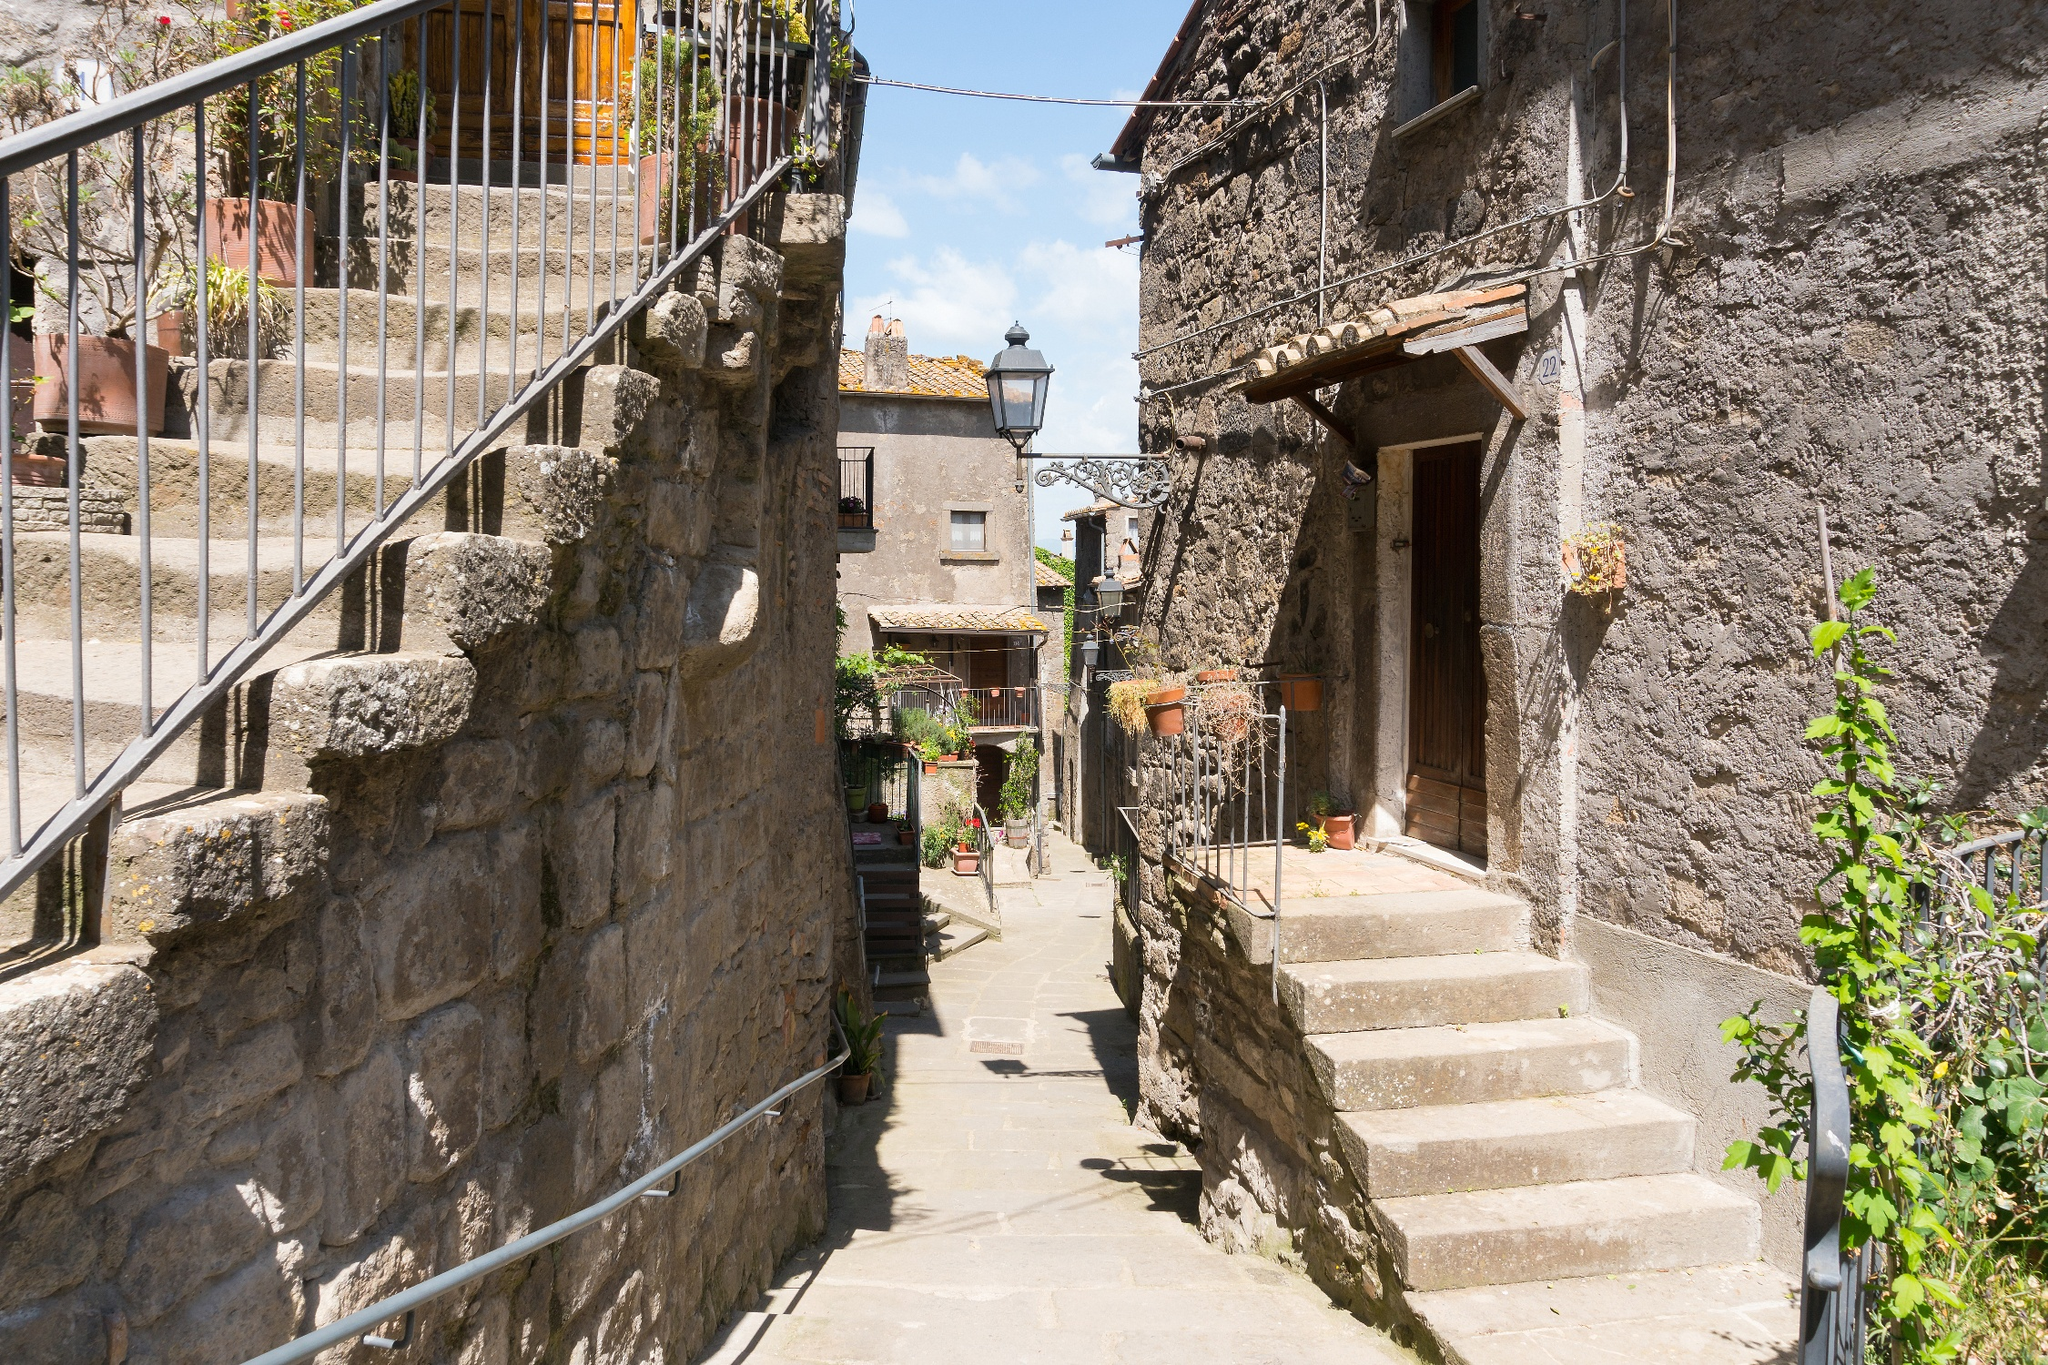How might this village be used as a setting in a historical novel? In a historical novel, this village could serve as the backdrop to a story set in medieval Europe. The narrative might revolve around a young blacksmith's apprentice named Jakob, living in a time of great turmoil. The alleyway, familiar to Jakob from childhood, becomes a battleground for covert meetings and secret messages. Jakob, drawn into a rebellion against a tyrannical lord, uses the intricate network of alleyways to evade capture and rally fellow villagers. The stone walls echo with the hushed conversations of conspirators and the hurried footsteps of messengers. The courtyard with its fountain becomes a rendezvous point for plotters planning the liberation of their village. As the story unfolds, the village transforms from a peaceful haven to a crucible of resistance, with every cobblestone and shadow playing a part in the tale of heroism and sacrifice. 